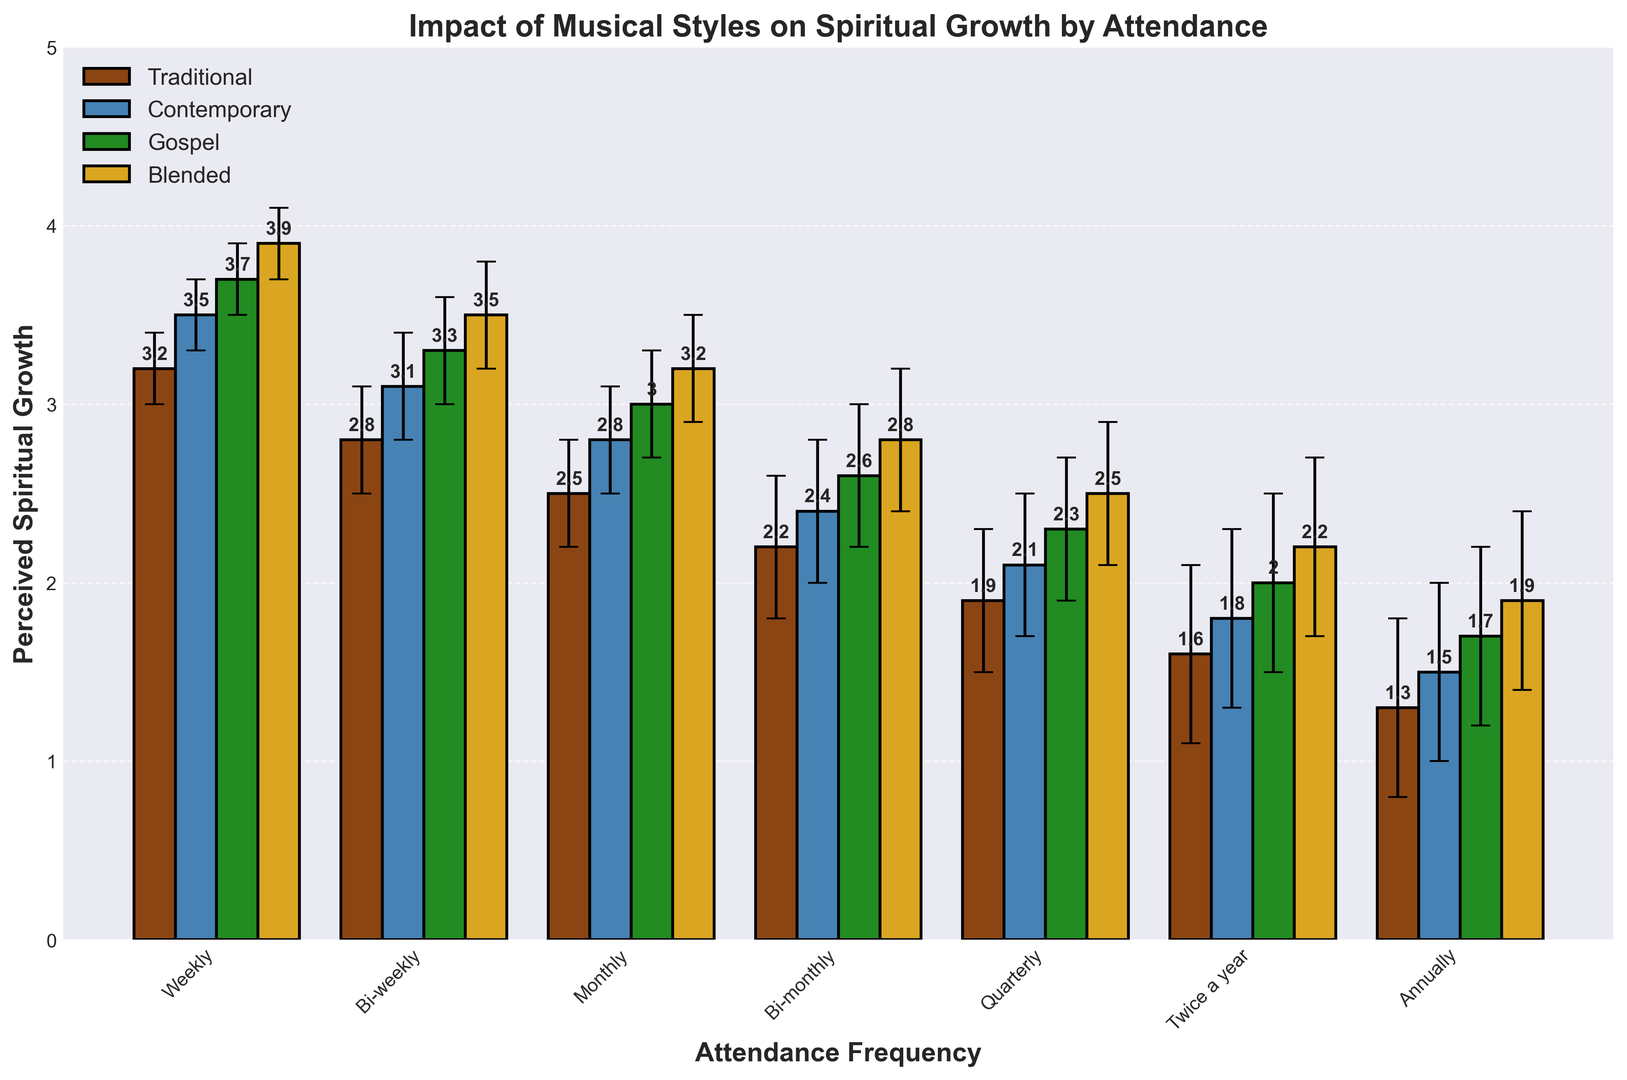What is the overall trend of perceived spiritual growth across different attendance frequencies? Perceived spiritual growth tends to decrease as the attendance frequency decreases, regardless of musical style. For instance, higher values are generally observed for weekly attendees and lower values for those attending less frequently such as annually.
Answer: Perceived spiritual growth decreases with lower attendance For which musical style and attendance frequency is the perceived spiritual growth the highest? The highest perceived spiritual growth is experienced with Blended Styles music for Weekly attendees. This is determined by observing the height of the bars, where the highest bar is 3.9 for Blended Styles music among weekly attendees.
Answer: Blended Styles for Weekly attendees How does the perceived spiritual growth for Traditional Music compare to Contemporary Music across all attendance frequencies? For all attendance frequencies, Contemporary Music yields slightly higher perceived spiritual growth values compared to Traditional Music. This is evident by comparing the bars of the two categories across each frequency group, where Contemporary Music consistently has higher values than Traditional Music.
Answer: Contemporary Music is consistently higher What is the difference in perceived spiritual growth between Gospel music for Weekly attendees and Traditional music for Monthly attendees? Gospel music for Weekly attendees has a perceived growth of 3.7, while Traditional music for Monthly attendees has a value of 2.5. Therefore, the difference is 3.7 - 2.5.
Answer: 1.2 Which musical style shows the least variation in perceived spiritual growth across all attendance frequencies? Traditional music exhibits the least variation in perceived spiritual growth across all attendance frequencies. This can be concluded as its bar heights are more consistent (ranging from 1.3 to 3.2) compared to the other musical styles.
Answer: Traditional Music Between which two attendance frequencies does Contemporary Music show the largest drop in perceived spiritual growth? The largest drop is observed between Weekly (3.5) and Bi-weekly (3.1) attendees. The difference is 3.5 - 3.1 = 0.4.
Answer: Weekly and Bi-weekly What is the sum of perceived spiritual growth values for all musical styles for Bi-monthly attendees? For Traditional Music (2.2), Contemporary Music (2.4), Gospel (2.6), and Blended Styles (2.8), the sum is 2.2 + 2.4 + 2.6 + 2.8.
Answer: 10.0 How does perceived spiritual growth for Blended Styles music compare to Gospel music at the Quarterly attendance frequency? At the Quarterly frequency, perceived spiritual growth for Blended Styles is 2.5, whereas for Gospel, it's 2.3. Therefore, Blended Styles has a slightly higher value than Gospel.
Answer: Blended Styles is higher What is the average perceived spiritual growth for all musical styles at Annually attendance frequency? The perceived spiritual growth values for Annually are 1.3 for Traditional, 1.5 for Contemporary, 1.7 for Gospel, and 1.9 for Blended Styles. Thus, the average is (1.3 + 1.5 + 1.7 + 1.9) / 4.
Answer: 1.6 What can be inferred about the impact of attendance on perceived spiritual growth when comparing the margins of error across groups? The margins of error increase as the attendance frequency decreases. This suggests more variability and less consistency in the perceived spiritual growth among less frequent attendees.
Answer: Increased variability with lower attendance How does the perceived spiritual growth for Contemporary music differ between Weekly and Annually attendees? For Weekly attendees, the perceived spiritual growth for Contemporary Music is 3.5, whereas for Annually attendees it is 1.5. The difference is 3.5 - 1.5.
Answer: 2.0 